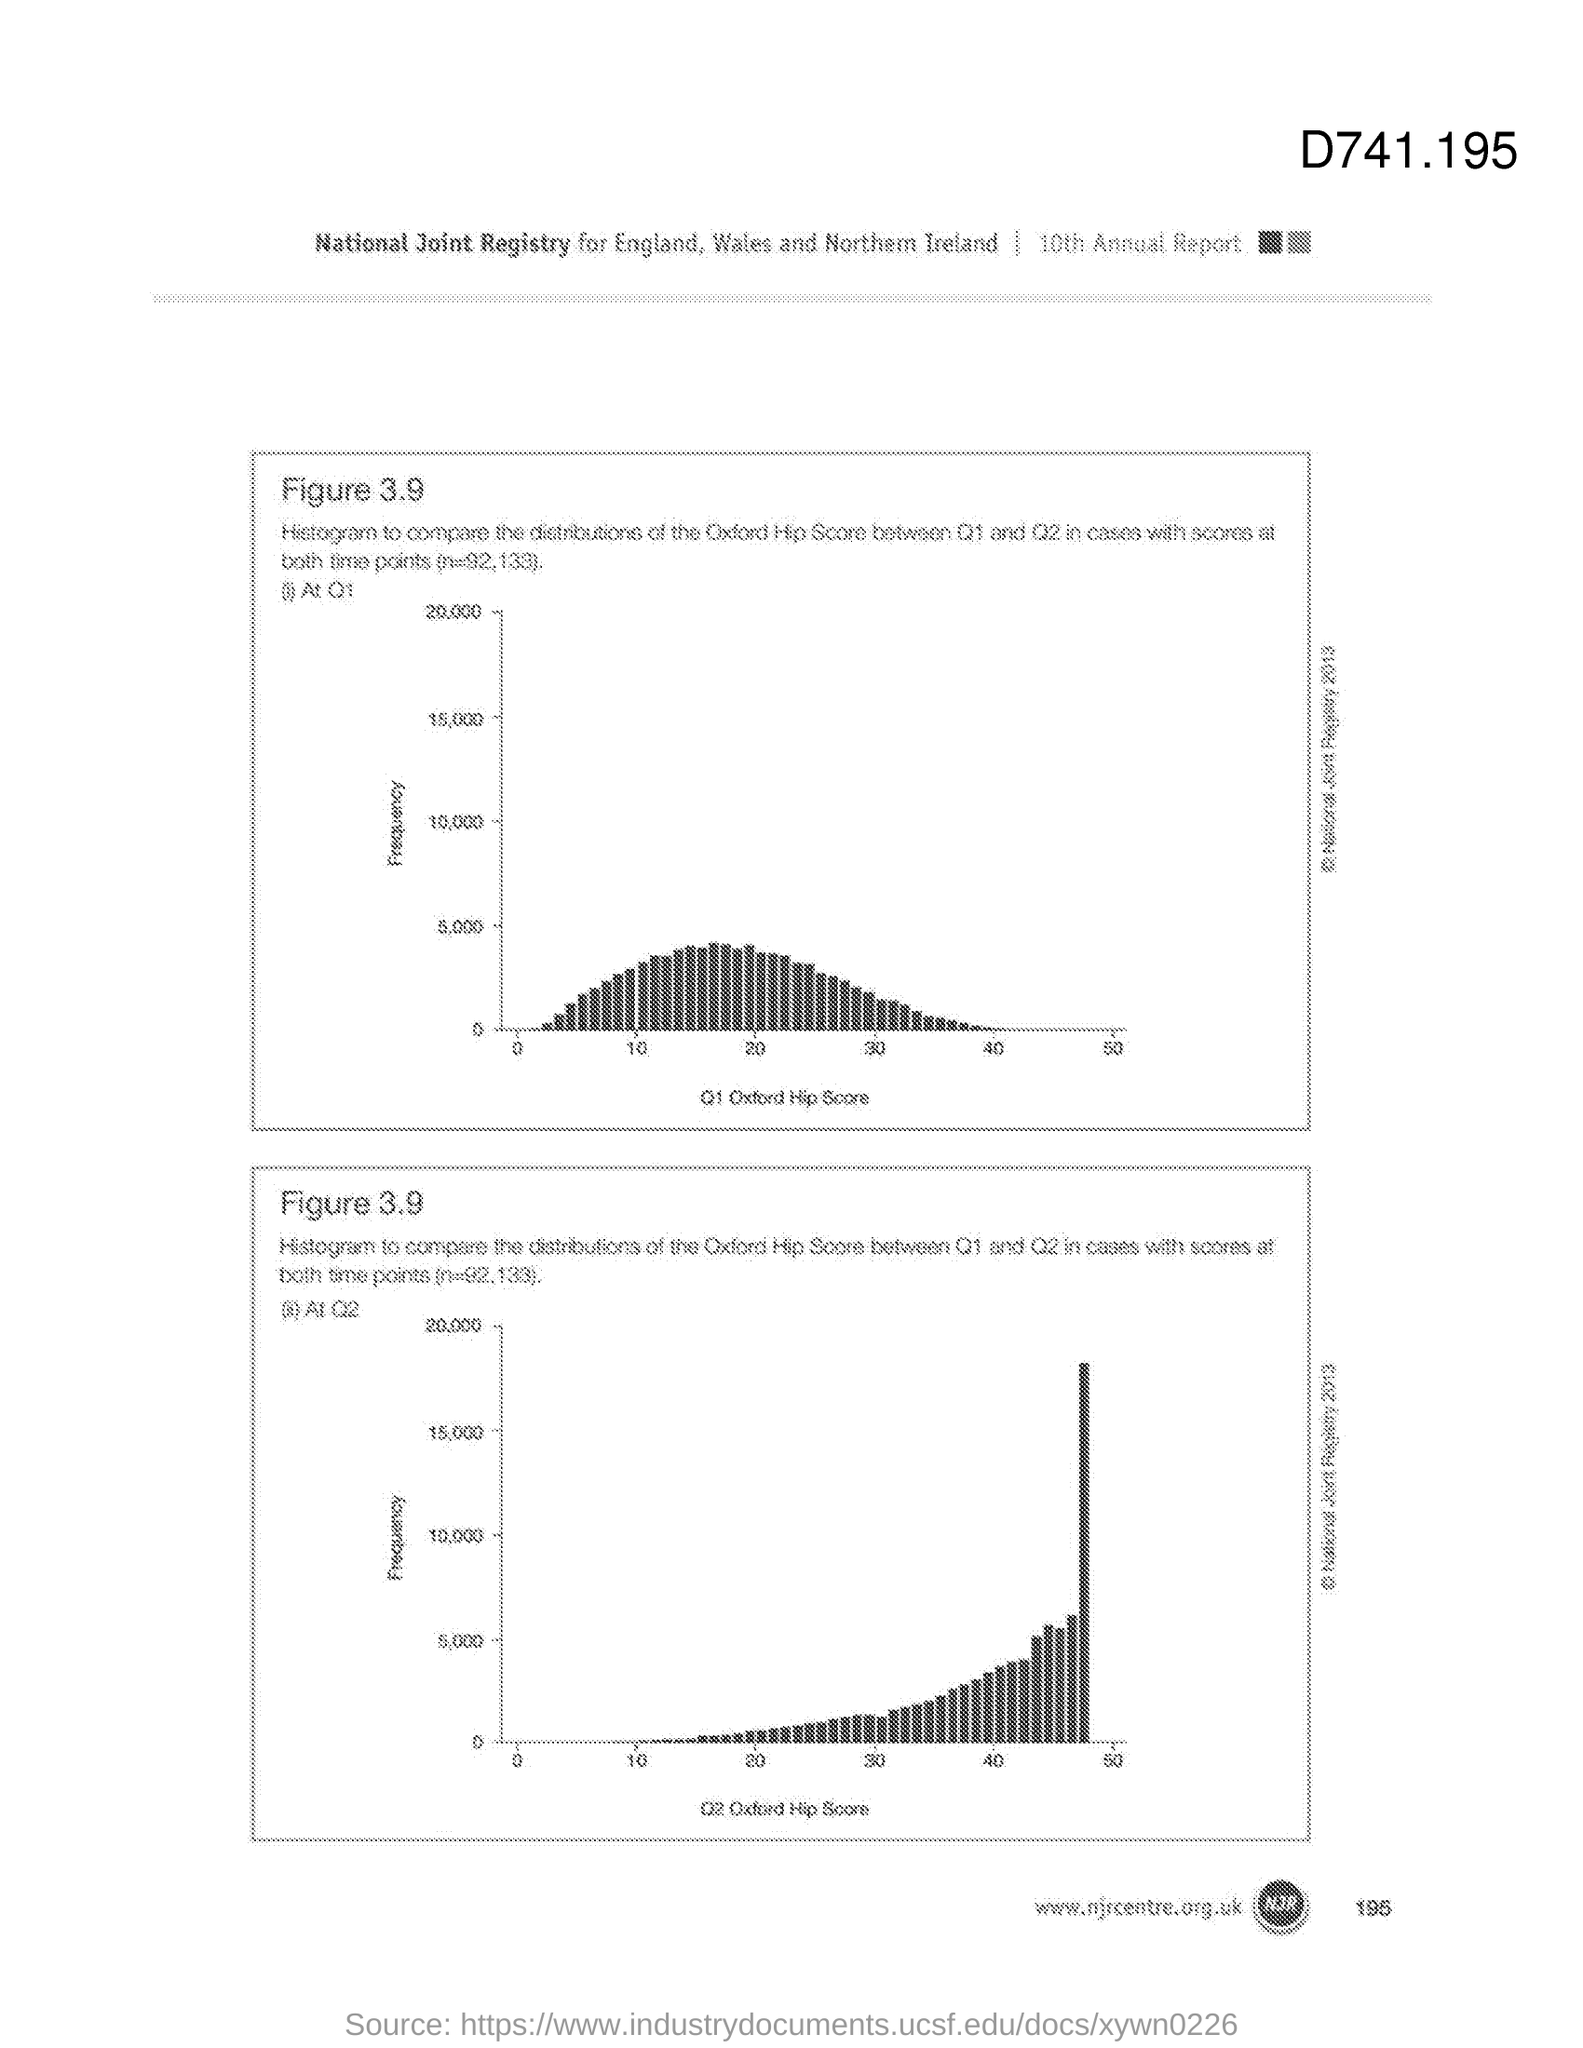What is the Page Number?
Make the answer very short. 195. What is the figure number?
Make the answer very short. 3.9. What is the edition of the annual report?
Provide a succinct answer. 10th. Which number is at the top right of the document?
Make the answer very short. 741.195. 